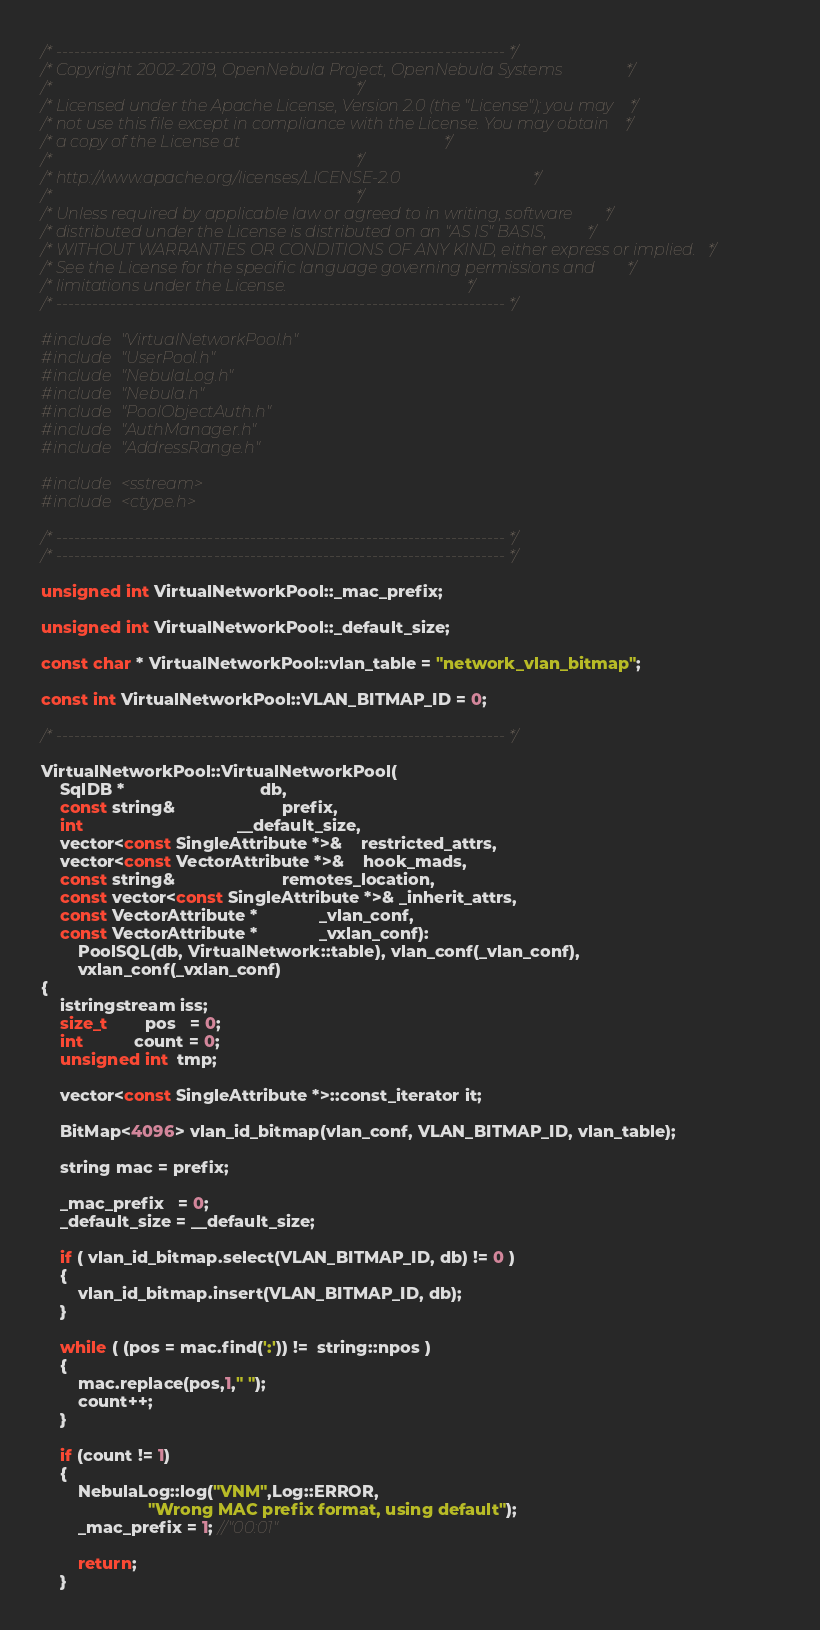Convert code to text. <code><loc_0><loc_0><loc_500><loc_500><_C++_>/* -------------------------------------------------------------------------- */
/* Copyright 2002-2019, OpenNebula Project, OpenNebula Systems                */
/*                                                                            */
/* Licensed under the Apache License, Version 2.0 (the "License"); you may    */
/* not use this file except in compliance with the License. You may obtain    */
/* a copy of the License at                                                   */
/*                                                                            */
/* http://www.apache.org/licenses/LICENSE-2.0                                 */
/*                                                                            */
/* Unless required by applicable law or agreed to in writing, software        */
/* distributed under the License is distributed on an "AS IS" BASIS,          */
/* WITHOUT WARRANTIES OR CONDITIONS OF ANY KIND, either express or implied.   */
/* See the License for the specific language governing permissions and        */
/* limitations under the License.                                             */
/* -------------------------------------------------------------------------- */

#include "VirtualNetworkPool.h"
#include "UserPool.h"
#include "NebulaLog.h"
#include "Nebula.h"
#include "PoolObjectAuth.h"
#include "AuthManager.h"
#include "AddressRange.h"

#include <sstream>
#include <ctype.h>

/* -------------------------------------------------------------------------- */
/* -------------------------------------------------------------------------- */

unsigned int VirtualNetworkPool::_mac_prefix;

unsigned int VirtualNetworkPool::_default_size;

const char * VirtualNetworkPool::vlan_table = "network_vlan_bitmap";

const int VirtualNetworkPool::VLAN_BITMAP_ID = 0;

/* -------------------------------------------------------------------------- */

VirtualNetworkPool::VirtualNetworkPool(
    SqlDB *                             db,
    const string&                       prefix,
    int                                 __default_size,
    vector<const SingleAttribute *>&    restricted_attrs,
    vector<const VectorAttribute *>&    hook_mads,
    const string&                       remotes_location,
    const vector<const SingleAttribute *>& _inherit_attrs,
    const VectorAttribute *             _vlan_conf,
    const VectorAttribute *             _vxlan_conf):
        PoolSQL(db, VirtualNetwork::table), vlan_conf(_vlan_conf),
        vxlan_conf(_vxlan_conf)
{
    istringstream iss;
    size_t        pos   = 0;
    int           count = 0;
    unsigned int  tmp;

    vector<const SingleAttribute *>::const_iterator it;

    BitMap<4096> vlan_id_bitmap(vlan_conf, VLAN_BITMAP_ID, vlan_table);

    string mac = prefix;

    _mac_prefix   = 0;
    _default_size = __default_size;

    if ( vlan_id_bitmap.select(VLAN_BITMAP_ID, db) != 0 )
    {
        vlan_id_bitmap.insert(VLAN_BITMAP_ID, db);
    }

    while ( (pos = mac.find(':')) !=  string::npos )
    {
        mac.replace(pos,1," ");
        count++;
    }

    if (count != 1)
    {
        NebulaLog::log("VNM",Log::ERROR,
                       "Wrong MAC prefix format, using default");
        _mac_prefix = 1; //"00:01"

        return;
    }
</code> 